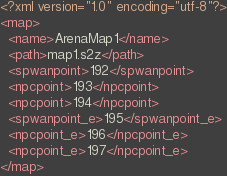<code> <loc_0><loc_0><loc_500><loc_500><_XML_><?xml version="1.0" encoding="utf-8"?>
<map>
  <name>ArenaMap1</name>
  <path>map1.s2z</path>
  <spwanpoint>192</spwanpoint>
  <npcpoint>193</npcpoint>
  <npcpoint>194</npcpoint>
  <spwanpoint_e>195</spwanpoint_e>
  <npcpoint_e>196</npcpoint_e>
  <npcpoint_e>197</npcpoint_e>
</map>
</code> 